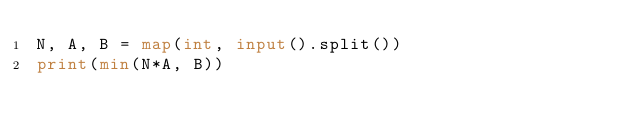Convert code to text. <code><loc_0><loc_0><loc_500><loc_500><_Python_>N, A, B = map(int, input().split())
print(min(N*A, B))</code> 